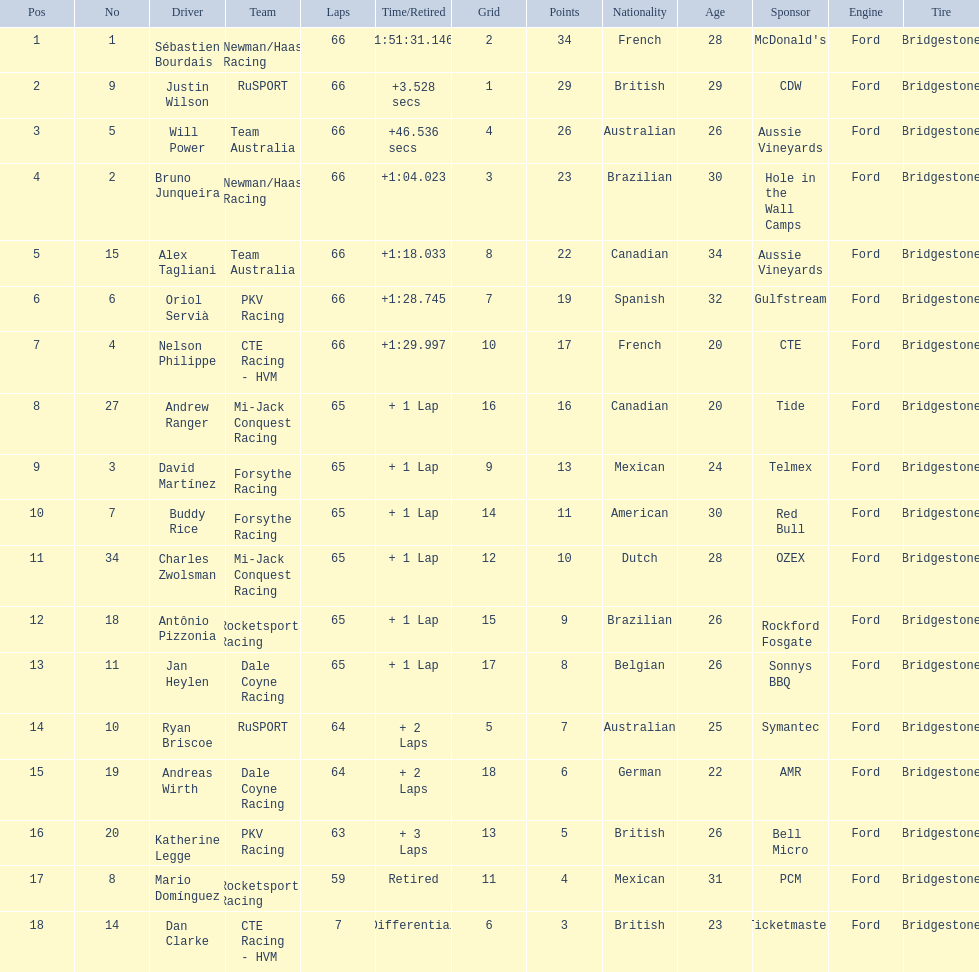Who are all the drivers? Sébastien Bourdais, Justin Wilson, Will Power, Bruno Junqueira, Alex Tagliani, Oriol Servià, Nelson Philippe, Andrew Ranger, David Martínez, Buddy Rice, Charles Zwolsman, Antônio Pizzonia, Jan Heylen, Ryan Briscoe, Andreas Wirth, Katherine Legge, Mario Domínguez, Dan Clarke. What position did they reach? 1, 2, 3, 4, 5, 6, 7, 8, 9, 10, 11, 12, 13, 14, 15, 16, 17, 18. What is the number for each driver? 1, 9, 5, 2, 15, 6, 4, 27, 3, 7, 34, 18, 11, 10, 19, 20, 8, 14. And which player's number and position match? Sébastien Bourdais. 